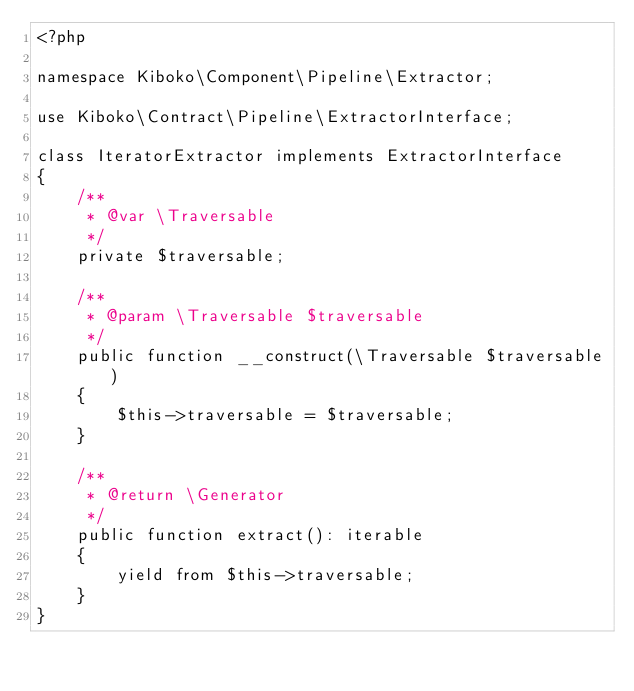Convert code to text. <code><loc_0><loc_0><loc_500><loc_500><_PHP_><?php

namespace Kiboko\Component\Pipeline\Extractor;

use Kiboko\Contract\Pipeline\ExtractorInterface;

class IteratorExtractor implements ExtractorInterface
{
    /**
     * @var \Traversable
     */
    private $traversable;

    /**
     * @param \Traversable $traversable
     */
    public function __construct(\Traversable $traversable)
    {
        $this->traversable = $traversable;
    }

    /**
     * @return \Generator
     */
    public function extract(): iterable
    {
        yield from $this->traversable;
    }
}
</code> 